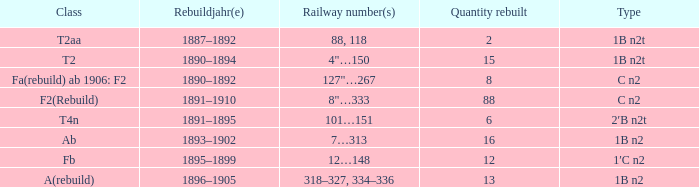What was the Rebuildjahr(e) for the T2AA class? 1887–1892. 